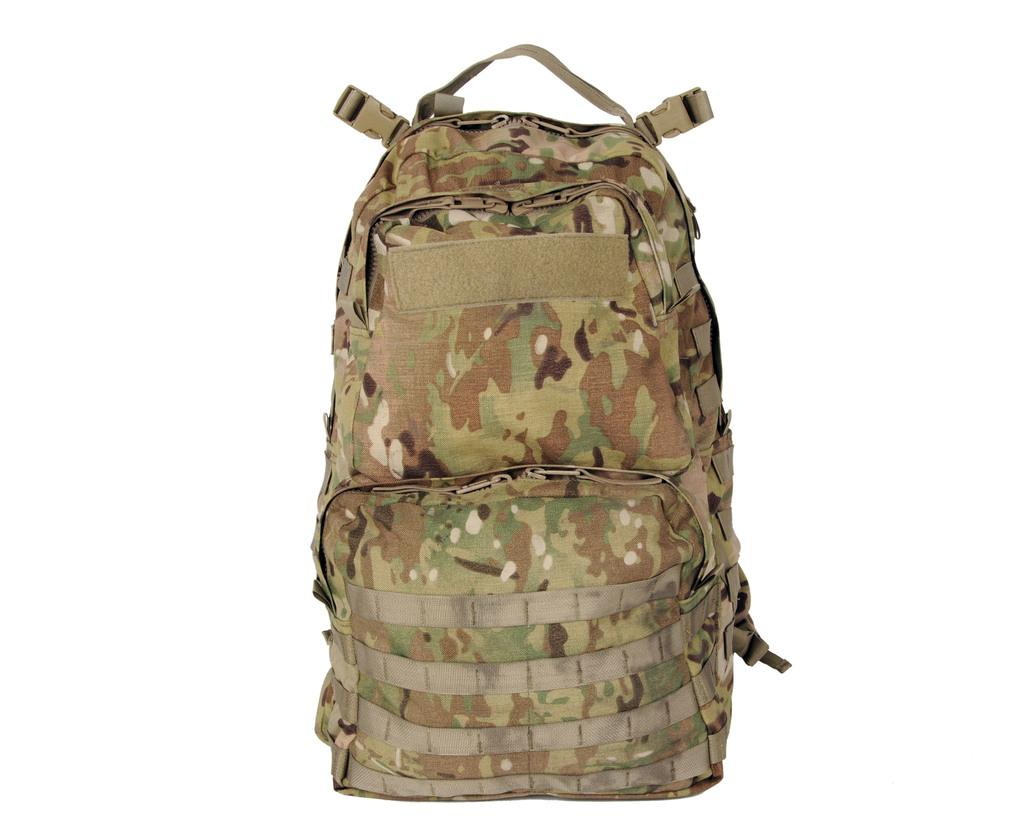What type of bag can be seen in the image? There is a brown color bag in the image. What type of coal is stored in the brown color bag in the image? There is no coal present in the image; it only shows a brown color bag. Can you see your mom wearing the brown color bag in the image? There is no person, including your mom, present in the image; it only shows a brown color bag. 